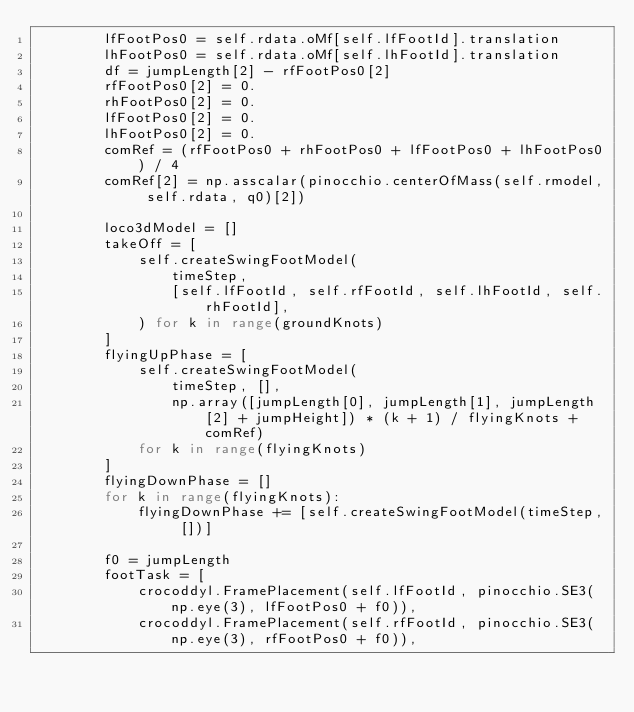<code> <loc_0><loc_0><loc_500><loc_500><_Python_>        lfFootPos0 = self.rdata.oMf[self.lfFootId].translation
        lhFootPos0 = self.rdata.oMf[self.lhFootId].translation
        df = jumpLength[2] - rfFootPos0[2]
        rfFootPos0[2] = 0.
        rhFootPos0[2] = 0.
        lfFootPos0[2] = 0.
        lhFootPos0[2] = 0.
        comRef = (rfFootPos0 + rhFootPos0 + lfFootPos0 + lhFootPos0) / 4
        comRef[2] = np.asscalar(pinocchio.centerOfMass(self.rmodel, self.rdata, q0)[2])

        loco3dModel = []
        takeOff = [
            self.createSwingFootModel(
                timeStep,
                [self.lfFootId, self.rfFootId, self.lhFootId, self.rhFootId],
            ) for k in range(groundKnots)
        ]
        flyingUpPhase = [
            self.createSwingFootModel(
                timeStep, [],
                np.array([jumpLength[0], jumpLength[1], jumpLength[2] + jumpHeight]) * (k + 1) / flyingKnots + comRef)
            for k in range(flyingKnots)
        ]
        flyingDownPhase = []
        for k in range(flyingKnots):
            flyingDownPhase += [self.createSwingFootModel(timeStep, [])]

        f0 = jumpLength
        footTask = [
            crocoddyl.FramePlacement(self.lfFootId, pinocchio.SE3(np.eye(3), lfFootPos0 + f0)),
            crocoddyl.FramePlacement(self.rfFootId, pinocchio.SE3(np.eye(3), rfFootPos0 + f0)),</code> 